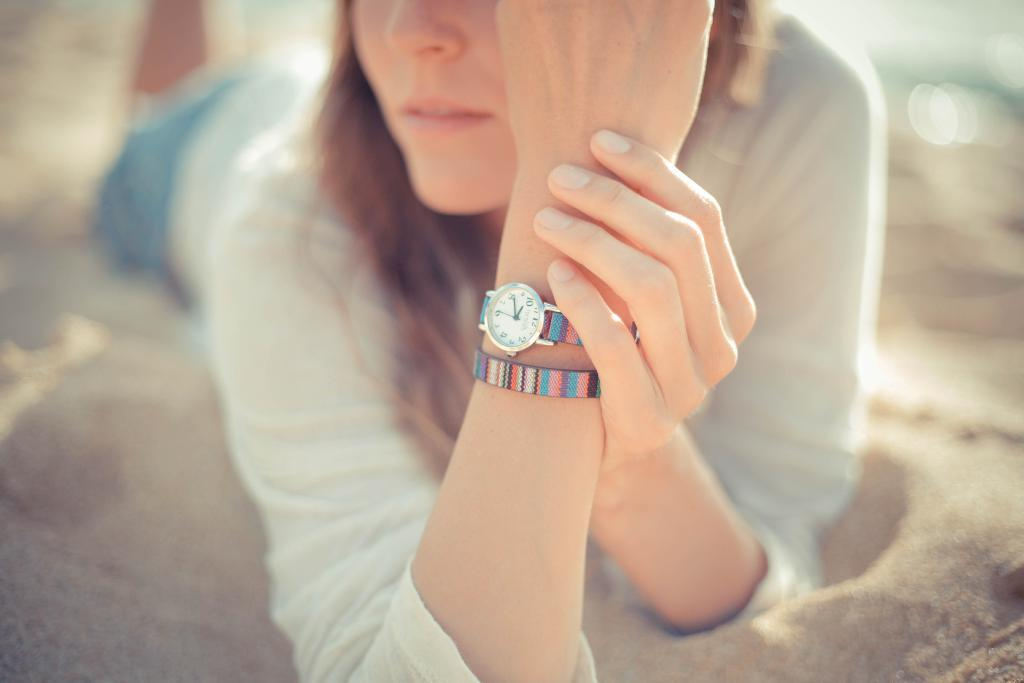What is the man doing in the image? The man is lying on the sand in the image. What type of clothing is the man wearing on his upper body? The man is wearing a t-shirt. What type of clothing is the man wearing on his lower body? The man is wearing shorts. What accessory is the man wearing on his wrist? The man is wearing a watch. What accessory is the man wearing on his head? The man is wearing a band. What type of crime is being committed in the image? There is no crime being committed in the image; it simply shows a man lying on the sand. What tool is the man using to perform magic in the image? There is no magic or tool present in the image; it only shows a man lying on the sand. 